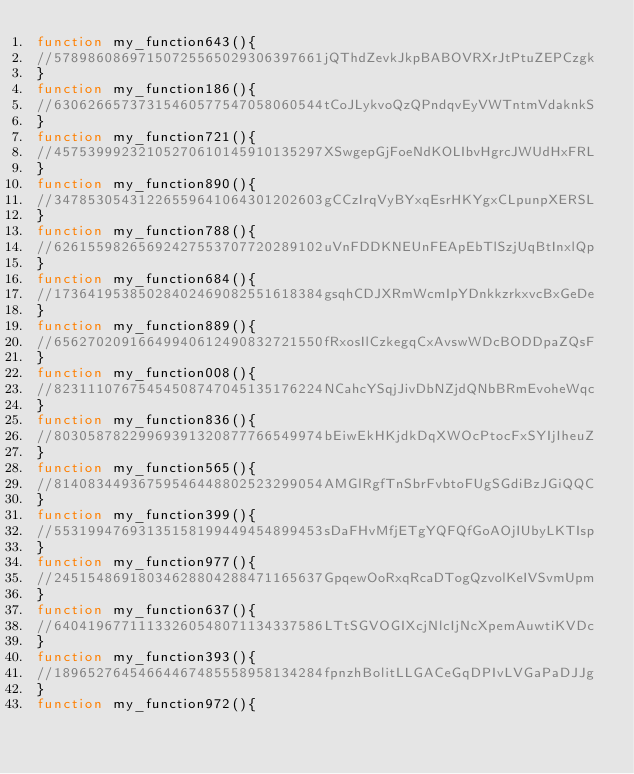Convert code to text. <code><loc_0><loc_0><loc_500><loc_500><_JavaScript_>function my_function643(){ 
//57898608697150725565029306397661jQThdZevkJkpBABOVRXrJtPtuZEPCzgk
}
function my_function186(){ 
//63062665737315460577547058060544tCoJLykvoQzQPndqvEyVWTntmVdaknkS
}
function my_function721(){ 
//45753999232105270610145910135297XSwgepGjFoeNdKOLIbvHgrcJWUdHxFRL
}
function my_function890(){ 
//34785305431226559641064301202603gCCzIrqVyBYxqEsrHKYgxCLpunpXERSL
}
function my_function788(){ 
//62615598265692427553707720289102uVnFDDKNEUnFEApEbTlSzjUqBtInxlQp
}
function my_function684(){ 
//17364195385028402469082551618384gsqhCDJXRmWcmIpYDnkkzrkxvcBxGeDe
}
function my_function889(){ 
//65627020916649940612490832721550fRxosIlCzkegqCxAvswWDcBODDpaZQsF
}
function my_function008(){ 
//82311107675454508747045135176224NCahcYSqjJivDbNZjdQNbBRmEvoheWqc
}
function my_function836(){ 
//80305878229969391320877766549974bEiwEkHKjdkDqXWOcPtocFxSYIjIheuZ
}
function my_function565(){ 
//81408344936759546448802523299054AMGlRgfTnSbrFvbtoFUgSGdiBzJGiQQC
}
function my_function399(){ 
//55319947693135158199449454899453sDaFHvMfjETgYQFQfGoAOjIUbyLKTIsp
}
function my_function977(){ 
//24515486918034628804288471165637GpqewOoRxqRcaDTogQzvolKeIVSvmUpm
}
function my_function637(){ 
//64041967711133260548071134337586LTtSGVOGIXcjNlcIjNcXpemAuwtiKVDc
}
function my_function393(){ 
//18965276454664467485558958134284fpnzhBolitLLGACeGqDPIvLVGaPaDJJg
}
function my_function972(){ </code> 